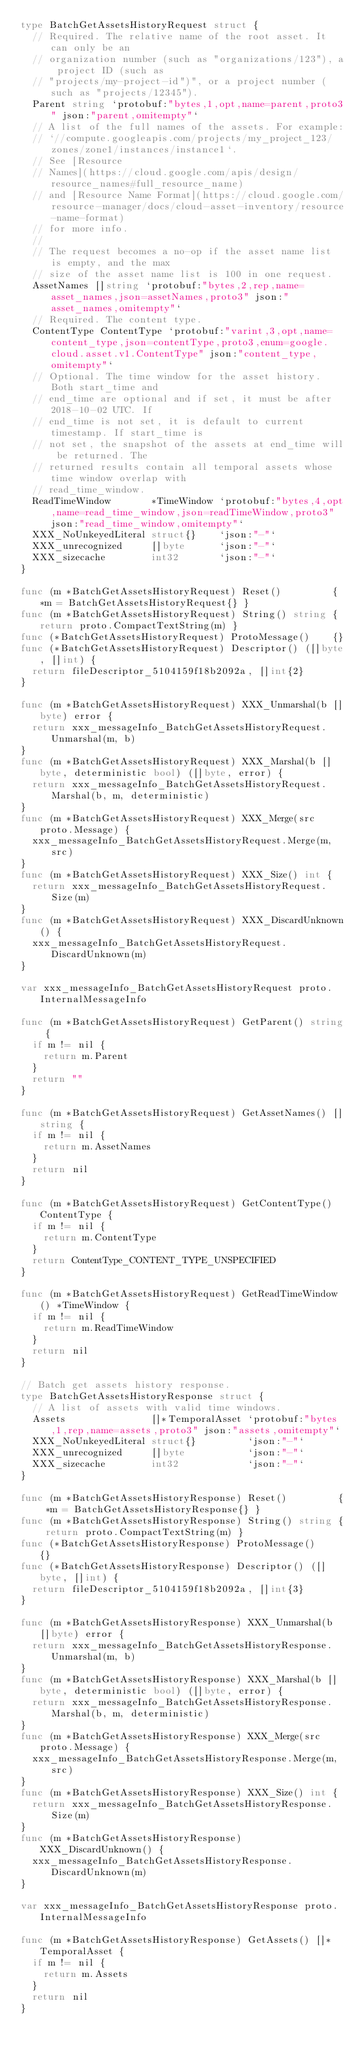<code> <loc_0><loc_0><loc_500><loc_500><_Go_>type BatchGetAssetsHistoryRequest struct {
	// Required. The relative name of the root asset. It can only be an
	// organization number (such as "organizations/123"), a project ID (such as
	// "projects/my-project-id")", or a project number (such as "projects/12345").
	Parent string `protobuf:"bytes,1,opt,name=parent,proto3" json:"parent,omitempty"`
	// A list of the full names of the assets. For example:
	// `//compute.googleapis.com/projects/my_project_123/zones/zone1/instances/instance1`.
	// See [Resource
	// Names](https://cloud.google.com/apis/design/resource_names#full_resource_name)
	// and [Resource Name Format](https://cloud.google.com/resource-manager/docs/cloud-asset-inventory/resource-name-format)
	// for more info.
	//
	// The request becomes a no-op if the asset name list is empty, and the max
	// size of the asset name list is 100 in one request.
	AssetNames []string `protobuf:"bytes,2,rep,name=asset_names,json=assetNames,proto3" json:"asset_names,omitempty"`
	// Required. The content type.
	ContentType ContentType `protobuf:"varint,3,opt,name=content_type,json=contentType,proto3,enum=google.cloud.asset.v1.ContentType" json:"content_type,omitempty"`
	// Optional. The time window for the asset history. Both start_time and
	// end_time are optional and if set, it must be after 2018-10-02 UTC. If
	// end_time is not set, it is default to current timestamp. If start_time is
	// not set, the snapshot of the assets at end_time will be returned. The
	// returned results contain all temporal assets whose time window overlap with
	// read_time_window.
	ReadTimeWindow       *TimeWindow `protobuf:"bytes,4,opt,name=read_time_window,json=readTimeWindow,proto3" json:"read_time_window,omitempty"`
	XXX_NoUnkeyedLiteral struct{}    `json:"-"`
	XXX_unrecognized     []byte      `json:"-"`
	XXX_sizecache        int32       `json:"-"`
}

func (m *BatchGetAssetsHistoryRequest) Reset()         { *m = BatchGetAssetsHistoryRequest{} }
func (m *BatchGetAssetsHistoryRequest) String() string { return proto.CompactTextString(m) }
func (*BatchGetAssetsHistoryRequest) ProtoMessage()    {}
func (*BatchGetAssetsHistoryRequest) Descriptor() ([]byte, []int) {
	return fileDescriptor_5104159f18b2092a, []int{2}
}

func (m *BatchGetAssetsHistoryRequest) XXX_Unmarshal(b []byte) error {
	return xxx_messageInfo_BatchGetAssetsHistoryRequest.Unmarshal(m, b)
}
func (m *BatchGetAssetsHistoryRequest) XXX_Marshal(b []byte, deterministic bool) ([]byte, error) {
	return xxx_messageInfo_BatchGetAssetsHistoryRequest.Marshal(b, m, deterministic)
}
func (m *BatchGetAssetsHistoryRequest) XXX_Merge(src proto.Message) {
	xxx_messageInfo_BatchGetAssetsHistoryRequest.Merge(m, src)
}
func (m *BatchGetAssetsHistoryRequest) XXX_Size() int {
	return xxx_messageInfo_BatchGetAssetsHistoryRequest.Size(m)
}
func (m *BatchGetAssetsHistoryRequest) XXX_DiscardUnknown() {
	xxx_messageInfo_BatchGetAssetsHistoryRequest.DiscardUnknown(m)
}

var xxx_messageInfo_BatchGetAssetsHistoryRequest proto.InternalMessageInfo

func (m *BatchGetAssetsHistoryRequest) GetParent() string {
	if m != nil {
		return m.Parent
	}
	return ""
}

func (m *BatchGetAssetsHistoryRequest) GetAssetNames() []string {
	if m != nil {
		return m.AssetNames
	}
	return nil
}

func (m *BatchGetAssetsHistoryRequest) GetContentType() ContentType {
	if m != nil {
		return m.ContentType
	}
	return ContentType_CONTENT_TYPE_UNSPECIFIED
}

func (m *BatchGetAssetsHistoryRequest) GetReadTimeWindow() *TimeWindow {
	if m != nil {
		return m.ReadTimeWindow
	}
	return nil
}

// Batch get assets history response.
type BatchGetAssetsHistoryResponse struct {
	// A list of assets with valid time windows.
	Assets               []*TemporalAsset `protobuf:"bytes,1,rep,name=assets,proto3" json:"assets,omitempty"`
	XXX_NoUnkeyedLiteral struct{}         `json:"-"`
	XXX_unrecognized     []byte           `json:"-"`
	XXX_sizecache        int32            `json:"-"`
}

func (m *BatchGetAssetsHistoryResponse) Reset()         { *m = BatchGetAssetsHistoryResponse{} }
func (m *BatchGetAssetsHistoryResponse) String() string { return proto.CompactTextString(m) }
func (*BatchGetAssetsHistoryResponse) ProtoMessage()    {}
func (*BatchGetAssetsHistoryResponse) Descriptor() ([]byte, []int) {
	return fileDescriptor_5104159f18b2092a, []int{3}
}

func (m *BatchGetAssetsHistoryResponse) XXX_Unmarshal(b []byte) error {
	return xxx_messageInfo_BatchGetAssetsHistoryResponse.Unmarshal(m, b)
}
func (m *BatchGetAssetsHistoryResponse) XXX_Marshal(b []byte, deterministic bool) ([]byte, error) {
	return xxx_messageInfo_BatchGetAssetsHistoryResponse.Marshal(b, m, deterministic)
}
func (m *BatchGetAssetsHistoryResponse) XXX_Merge(src proto.Message) {
	xxx_messageInfo_BatchGetAssetsHistoryResponse.Merge(m, src)
}
func (m *BatchGetAssetsHistoryResponse) XXX_Size() int {
	return xxx_messageInfo_BatchGetAssetsHistoryResponse.Size(m)
}
func (m *BatchGetAssetsHistoryResponse) XXX_DiscardUnknown() {
	xxx_messageInfo_BatchGetAssetsHistoryResponse.DiscardUnknown(m)
}

var xxx_messageInfo_BatchGetAssetsHistoryResponse proto.InternalMessageInfo

func (m *BatchGetAssetsHistoryResponse) GetAssets() []*TemporalAsset {
	if m != nil {
		return m.Assets
	}
	return nil
}
</code> 